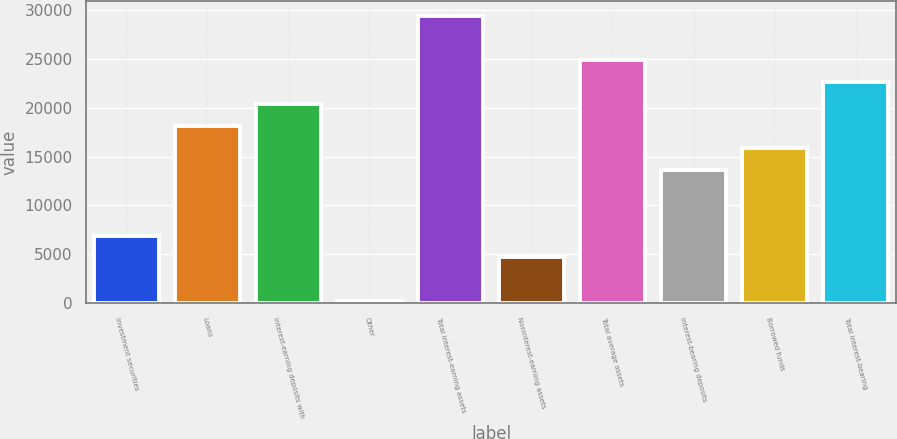Convert chart to OTSL. <chart><loc_0><loc_0><loc_500><loc_500><bar_chart><fcel>Investment securities<fcel>Loans<fcel>Interest-earning deposits with<fcel>Other<fcel>Total interest-earning assets<fcel>Noninterest-earning assets<fcel>Total average assets<fcel>Interest-bearing deposits<fcel>Borrowed funds<fcel>Total interest-bearing<nl><fcel>6931<fcel>18166<fcel>20413<fcel>190<fcel>29401<fcel>4684<fcel>24907<fcel>13672<fcel>15919<fcel>22660<nl></chart> 